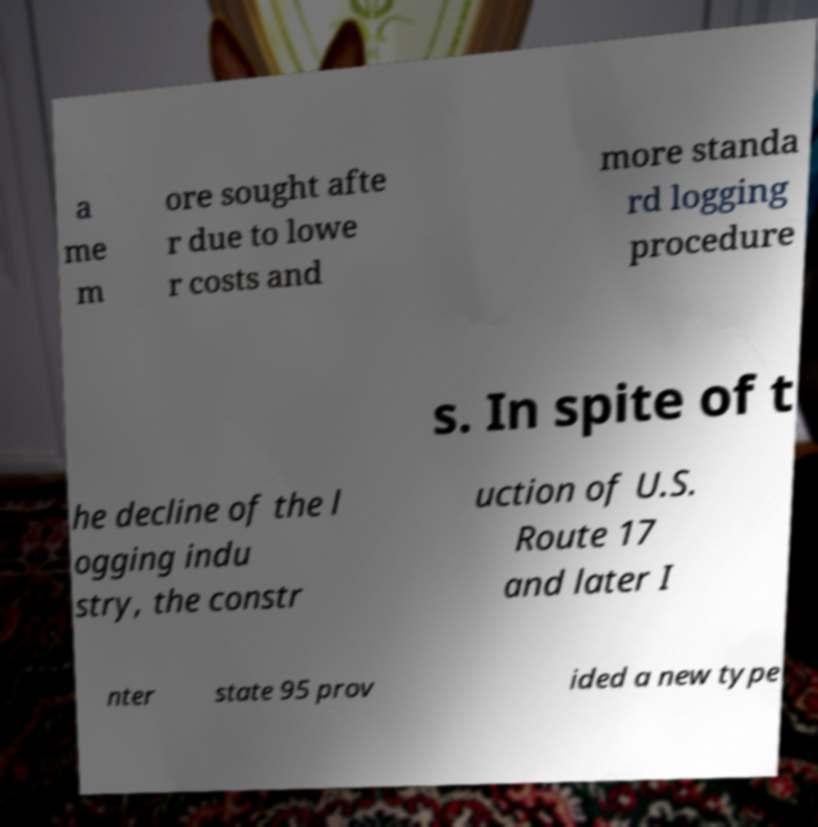Please identify and transcribe the text found in this image. a me m ore sought afte r due to lowe r costs and more standa rd logging procedure s. In spite of t he decline of the l ogging indu stry, the constr uction of U.S. Route 17 and later I nter state 95 prov ided a new type 